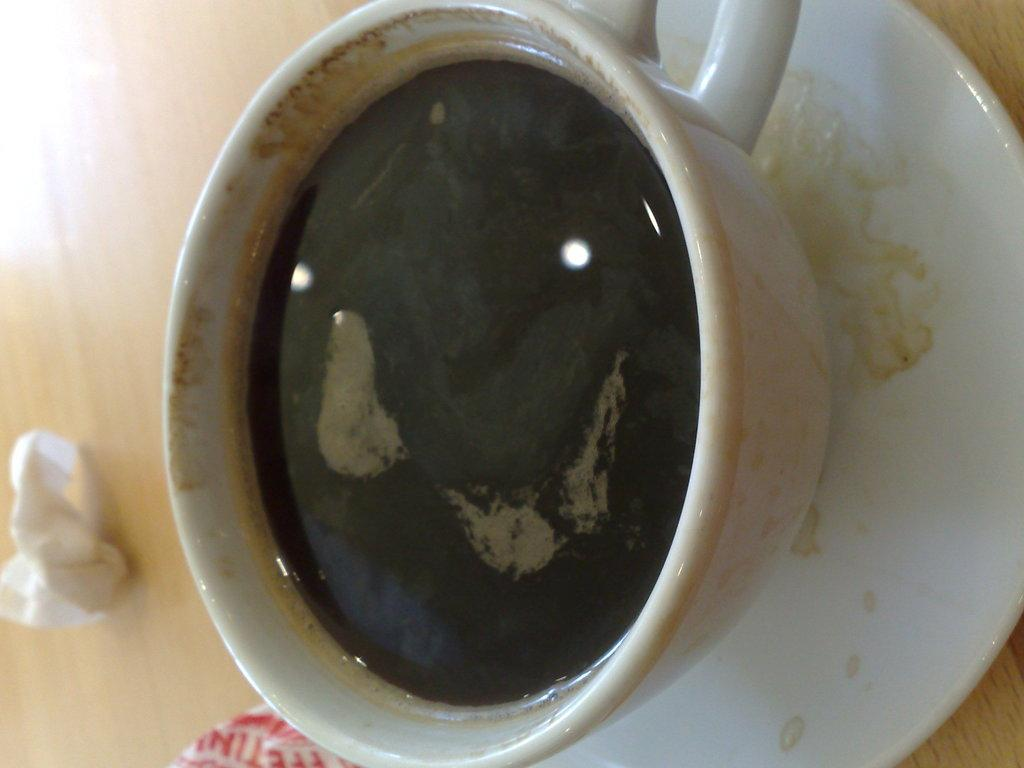What is in the cup that is visible in the image? There is a liquid in the cup in the image. What is the cup resting on in the image? The cup is on a saucer. What can be seen in the background of the image? There is a tissue and an object on the table in the background of the image. What type of square shirt is visible in the image? There is no shirt, square or otherwise, present in the image. How many cakes are on the table in the image? There is no mention of cakes in the image; the only object mentioned on the table is an unspecified object in the background. 